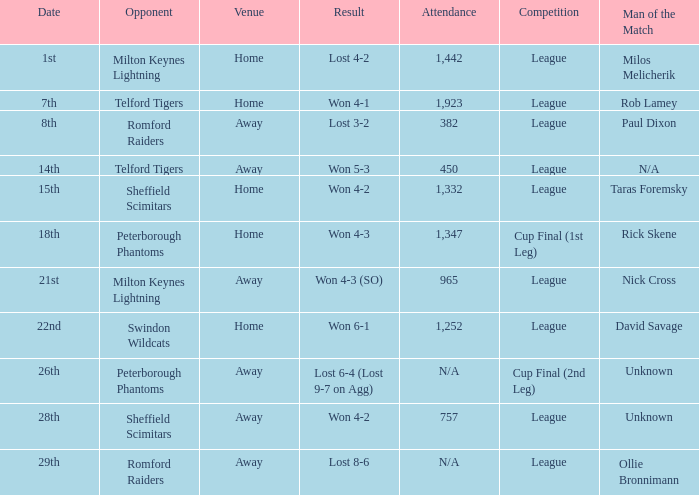What competition was held on the 26th? Cup Final (2nd Leg). 